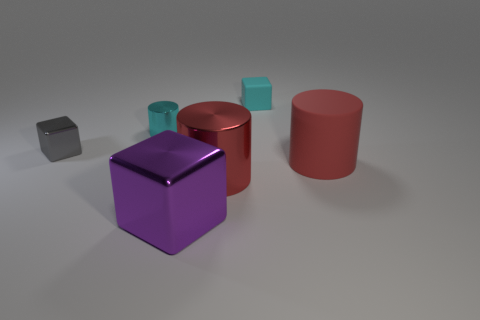Subtract all metal cubes. How many cubes are left? 1 Add 1 large red metal cylinders. How many objects exist? 7 Subtract all large purple metal blocks. Subtract all red metal cylinders. How many objects are left? 4 Add 3 red rubber objects. How many red rubber objects are left? 4 Add 5 large purple matte cylinders. How many large purple matte cylinders exist? 5 Subtract 0 yellow cylinders. How many objects are left? 6 